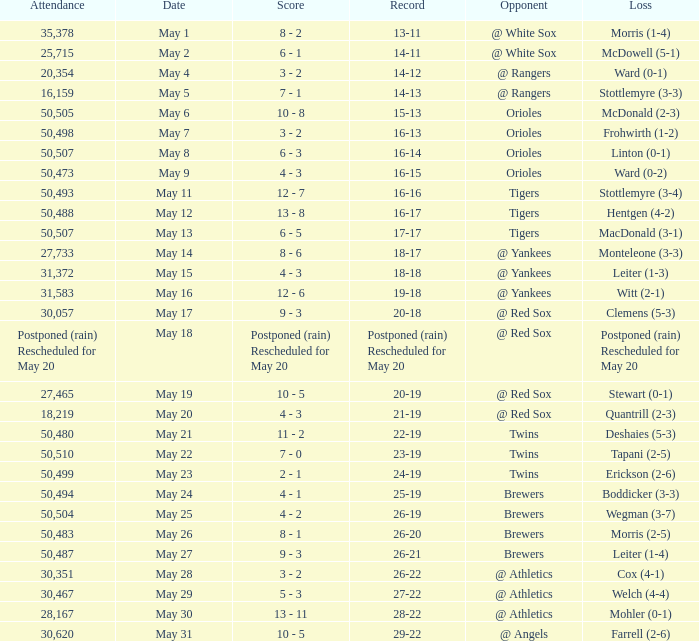What team did they lose to when they had a 28-22 record? Mohler (0-1). 